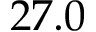Convert formula to latex. <formula><loc_0><loc_0><loc_500><loc_500>2 7 . 0</formula> 